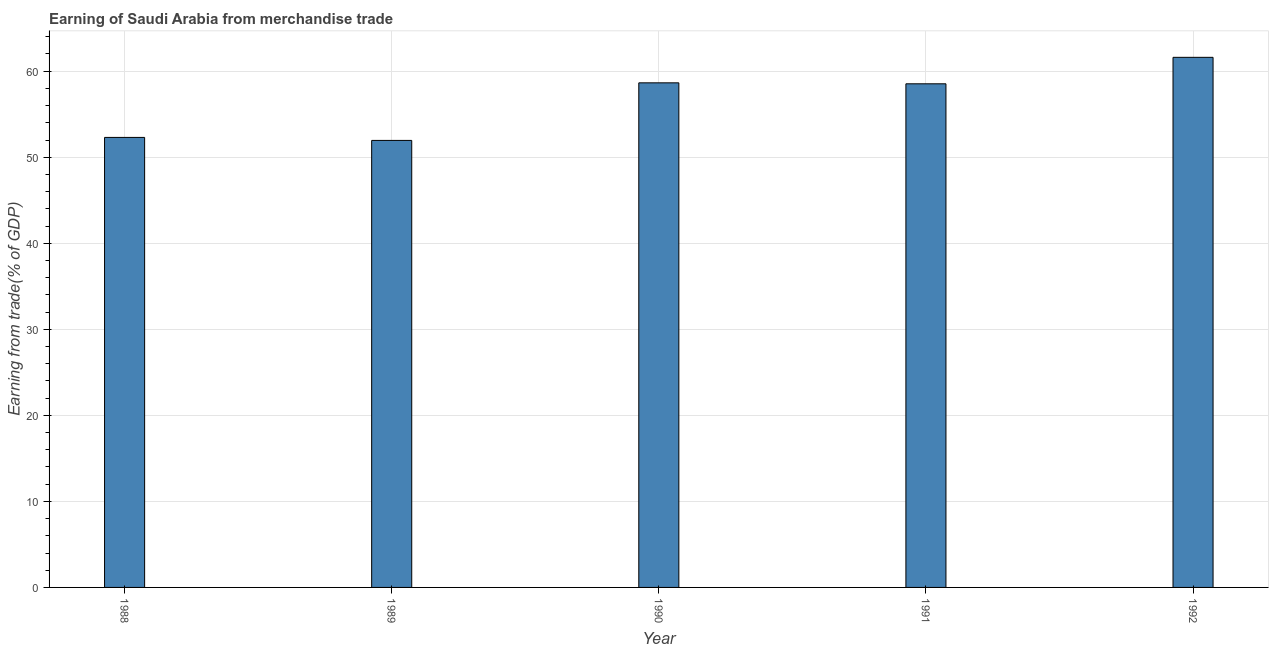What is the title of the graph?
Your response must be concise. Earning of Saudi Arabia from merchandise trade. What is the label or title of the X-axis?
Your response must be concise. Year. What is the label or title of the Y-axis?
Provide a succinct answer. Earning from trade(% of GDP). What is the earning from merchandise trade in 1988?
Offer a very short reply. 52.3. Across all years, what is the maximum earning from merchandise trade?
Your answer should be compact. 61.61. Across all years, what is the minimum earning from merchandise trade?
Make the answer very short. 51.95. What is the sum of the earning from merchandise trade?
Ensure brevity in your answer.  283.05. What is the difference between the earning from merchandise trade in 1989 and 1991?
Provide a succinct answer. -6.58. What is the average earning from merchandise trade per year?
Keep it short and to the point. 56.61. What is the median earning from merchandise trade?
Ensure brevity in your answer.  58.53. In how many years, is the earning from merchandise trade greater than 24 %?
Your answer should be very brief. 5. What is the ratio of the earning from merchandise trade in 1988 to that in 1992?
Keep it short and to the point. 0.85. What is the difference between the highest and the second highest earning from merchandise trade?
Offer a very short reply. 2.96. What is the difference between the highest and the lowest earning from merchandise trade?
Offer a very short reply. 9.66. In how many years, is the earning from merchandise trade greater than the average earning from merchandise trade taken over all years?
Your answer should be compact. 3. Are all the bars in the graph horizontal?
Your answer should be very brief. No. How many years are there in the graph?
Make the answer very short. 5. What is the Earning from trade(% of GDP) of 1988?
Your response must be concise. 52.3. What is the Earning from trade(% of GDP) in 1989?
Provide a short and direct response. 51.95. What is the Earning from trade(% of GDP) in 1990?
Your response must be concise. 58.65. What is the Earning from trade(% of GDP) of 1991?
Your answer should be very brief. 58.53. What is the Earning from trade(% of GDP) in 1992?
Your answer should be very brief. 61.61. What is the difference between the Earning from trade(% of GDP) in 1988 and 1989?
Provide a short and direct response. 0.35. What is the difference between the Earning from trade(% of GDP) in 1988 and 1990?
Offer a very short reply. -6.34. What is the difference between the Earning from trade(% of GDP) in 1988 and 1991?
Provide a short and direct response. -6.23. What is the difference between the Earning from trade(% of GDP) in 1988 and 1992?
Ensure brevity in your answer.  -9.31. What is the difference between the Earning from trade(% of GDP) in 1989 and 1990?
Your answer should be very brief. -6.69. What is the difference between the Earning from trade(% of GDP) in 1989 and 1991?
Your answer should be compact. -6.58. What is the difference between the Earning from trade(% of GDP) in 1989 and 1992?
Your answer should be very brief. -9.66. What is the difference between the Earning from trade(% of GDP) in 1990 and 1991?
Offer a very short reply. 0.11. What is the difference between the Earning from trade(% of GDP) in 1990 and 1992?
Provide a short and direct response. -2.96. What is the difference between the Earning from trade(% of GDP) in 1991 and 1992?
Your response must be concise. -3.08. What is the ratio of the Earning from trade(% of GDP) in 1988 to that in 1989?
Ensure brevity in your answer.  1.01. What is the ratio of the Earning from trade(% of GDP) in 1988 to that in 1990?
Your answer should be very brief. 0.89. What is the ratio of the Earning from trade(% of GDP) in 1988 to that in 1991?
Your answer should be compact. 0.89. What is the ratio of the Earning from trade(% of GDP) in 1988 to that in 1992?
Keep it short and to the point. 0.85. What is the ratio of the Earning from trade(% of GDP) in 1989 to that in 1990?
Make the answer very short. 0.89. What is the ratio of the Earning from trade(% of GDP) in 1989 to that in 1991?
Offer a terse response. 0.89. What is the ratio of the Earning from trade(% of GDP) in 1989 to that in 1992?
Offer a terse response. 0.84. What is the ratio of the Earning from trade(% of GDP) in 1990 to that in 1991?
Your answer should be very brief. 1. What is the ratio of the Earning from trade(% of GDP) in 1990 to that in 1992?
Keep it short and to the point. 0.95. 